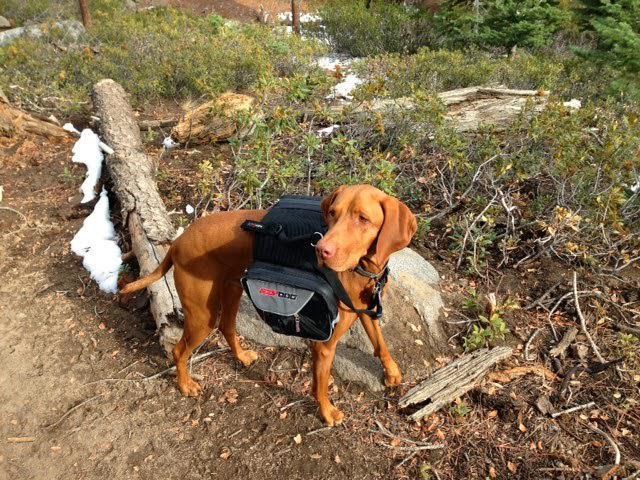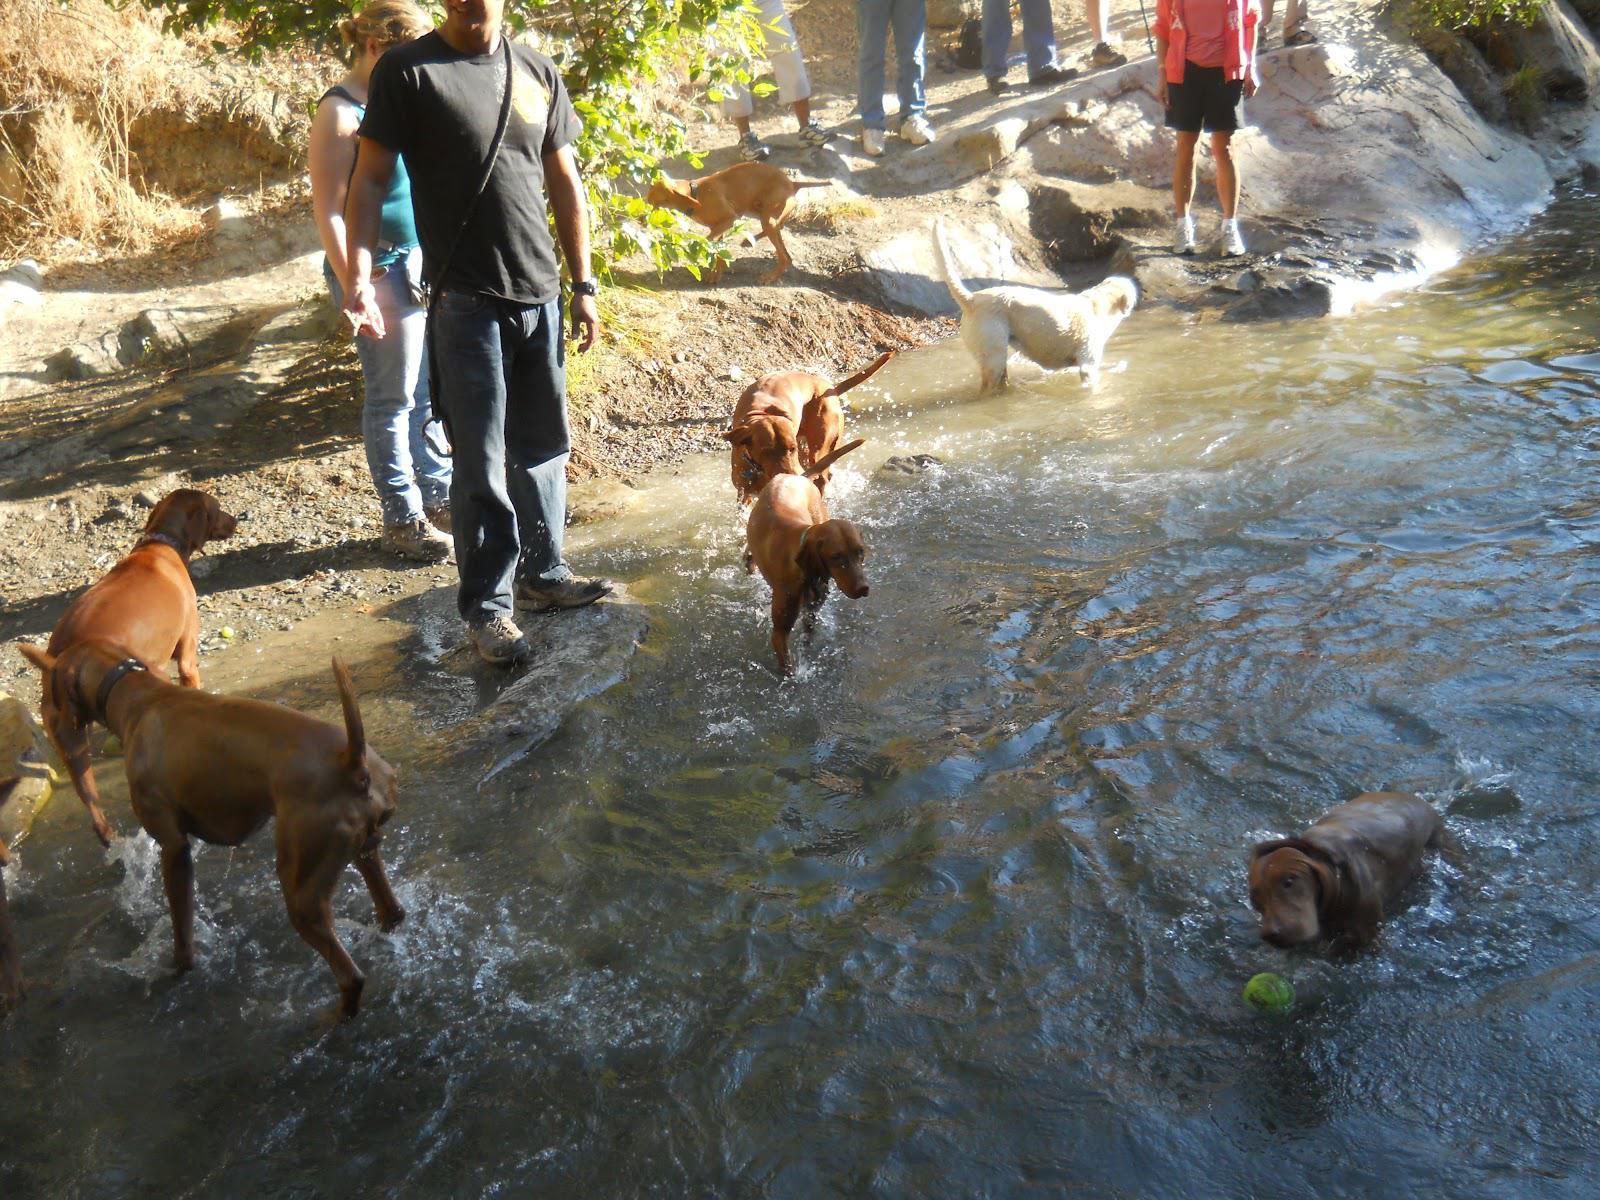The first image is the image on the left, the second image is the image on the right. Considering the images on both sides, is "In at least one image there are two hunting dogs with collars on." valid? Answer yes or no. No. The first image is the image on the left, the second image is the image on the right. Given the left and right images, does the statement "In the right image, red-orange dogs are on each side of a man with a strap on his front." hold true? Answer yes or no. Yes. 